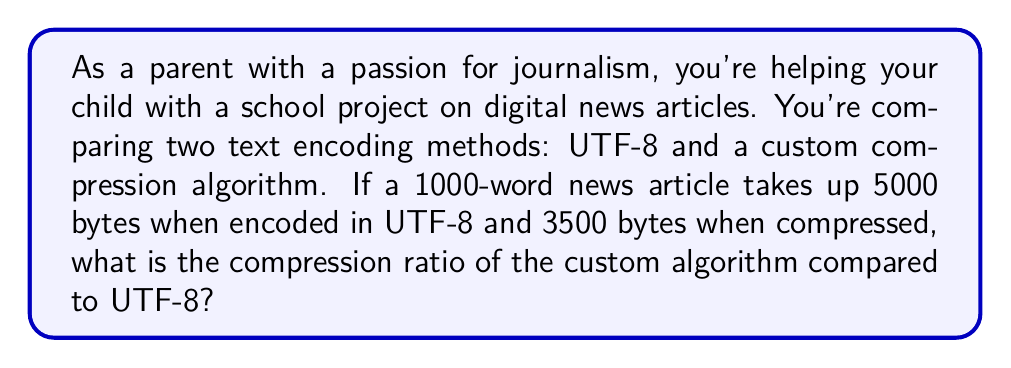Teach me how to tackle this problem. To solve this problem, we need to understand the concept of compression ratio and how to calculate it. The compression ratio is a measure of how much the data size is reduced by compression. It's typically expressed as:

$$ \text{Compression Ratio} = \frac{\text{Uncompressed Size}}{\text{Compressed Size}} $$

In this case:
1. The uncompressed size (UTF-8 encoding) is 5000 bytes
2. The compressed size (custom algorithm) is 3500 bytes

Let's plug these values into the formula:

$$ \text{Compression Ratio} = \frac{5000 \text{ bytes}}{3500 \text{ bytes}} $$

Now, let's perform the division:

$$ \text{Compression Ratio} = 1.4285714... $$

We can round this to two decimal places for a more practical representation.

$$ \text{Compression Ratio} \approx 1.43 $$

This means that the custom compression algorithm can store the same information in about 70% (1/1.43) of the space required by UTF-8 encoding.

To express this as a percentage of space saved, we can use:

$$ \text{Space Saved} = (1 - \frac{1}{\text{Compression Ratio}}) \times 100\% $$

$$ \text{Space Saved} = (1 - \frac{1}{1.43}) \times 100\% \approx 30\% $$

So, the custom compression algorithm saves about 30% of space compared to UTF-8 encoding.
Answer: The compression ratio of the custom algorithm compared to UTF-8 is approximately 1.43:1, or 1.43. 